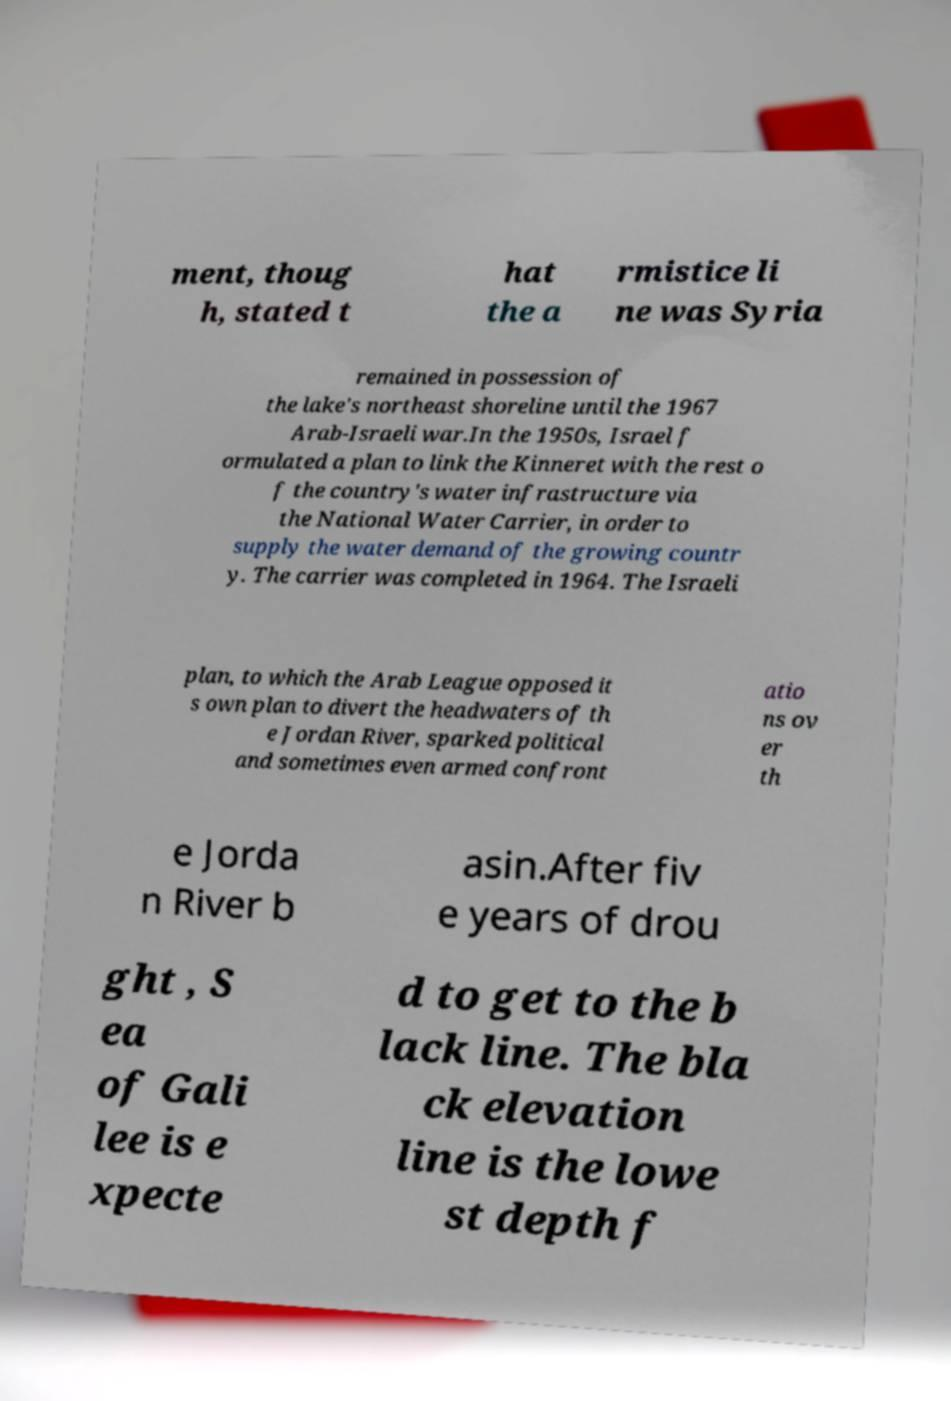Could you extract and type out the text from this image? ment, thoug h, stated t hat the a rmistice li ne was Syria remained in possession of the lake's northeast shoreline until the 1967 Arab-Israeli war.In the 1950s, Israel f ormulated a plan to link the Kinneret with the rest o f the country's water infrastructure via the National Water Carrier, in order to supply the water demand of the growing countr y. The carrier was completed in 1964. The Israeli plan, to which the Arab League opposed it s own plan to divert the headwaters of th e Jordan River, sparked political and sometimes even armed confront atio ns ov er th e Jorda n River b asin.After fiv e years of drou ght , S ea of Gali lee is e xpecte d to get to the b lack line. The bla ck elevation line is the lowe st depth f 